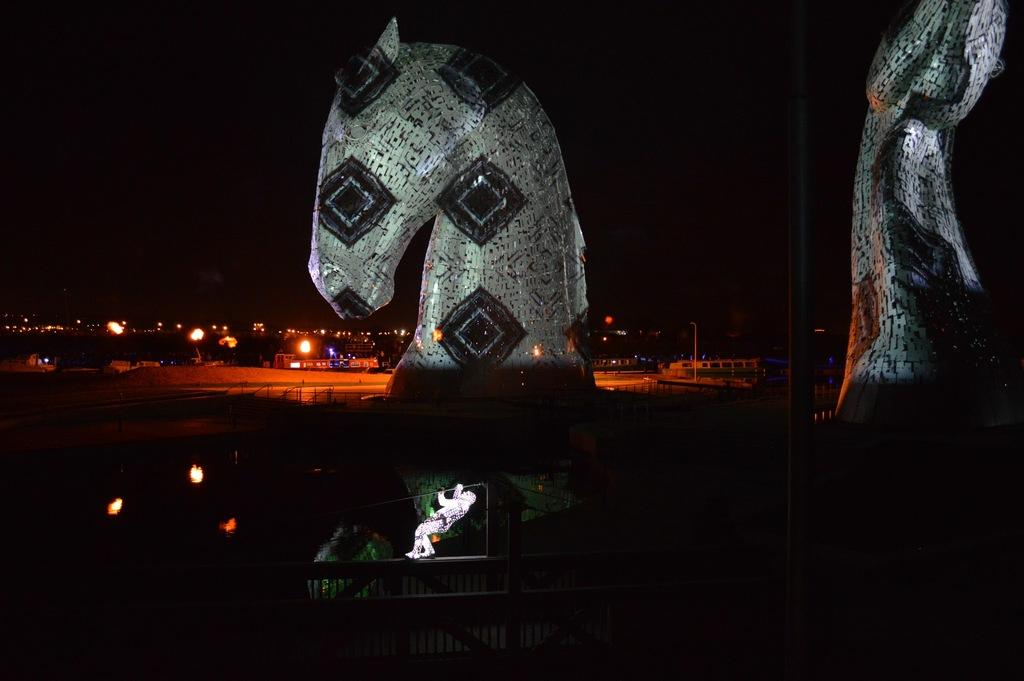What is the main subject in the middle of the image? There is a person in the middle of the image. What other objects or structures can be seen in the image? There are statues in the image. What can be seen in the background of the image? There are lights in the background of the image. What is visible at the top of the image? The sky is visible at the top of the image. What type of coal is being used to draw on the chalkboard in the image? There is no chalkboard or coal present in the image. What is the profit margin of the person in the image? There is no information about profit margins in the image. 